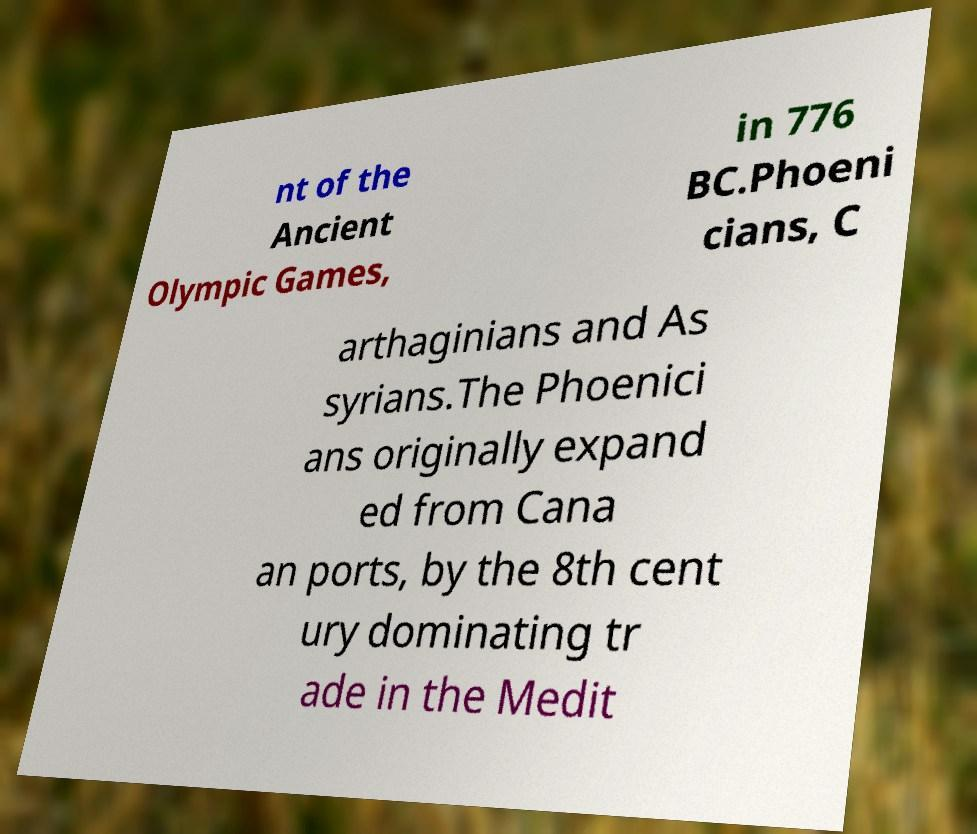I need the written content from this picture converted into text. Can you do that? nt of the Ancient Olympic Games, in 776 BC.Phoeni cians, C arthaginians and As syrians.The Phoenici ans originally expand ed from Cana an ports, by the 8th cent ury dominating tr ade in the Medit 